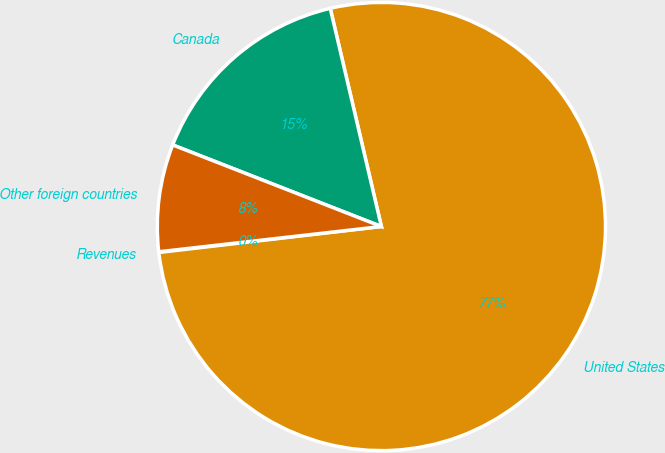Convert chart to OTSL. <chart><loc_0><loc_0><loc_500><loc_500><pie_chart><fcel>Revenues<fcel>United States<fcel>Canada<fcel>Other foreign countries<nl><fcel>0.05%<fcel>76.81%<fcel>15.4%<fcel>7.73%<nl></chart> 